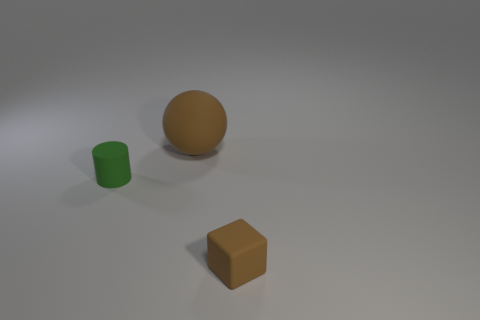What shape is the tiny object that is the same color as the big ball?
Your answer should be very brief. Cube. Is the color of the tiny object in front of the cylinder the same as the thing to the left of the matte ball?
Provide a succinct answer. No. What number of brown matte things are in front of the tiny cylinder?
Offer a very short reply. 1. There is a matte cube that is the same color as the big matte sphere; what is its size?
Keep it short and to the point. Small. Is there a small matte object that has the same shape as the large brown object?
Keep it short and to the point. No. What color is the matte cylinder that is the same size as the brown cube?
Offer a terse response. Green. Is the number of brown balls in front of the sphere less than the number of large matte balls behind the tiny rubber block?
Your response must be concise. Yes. There is a rubber thing in front of the green matte thing; is its size the same as the green matte object?
Your answer should be compact. Yes. There is a brown matte object that is in front of the rubber cylinder; what is its shape?
Give a very brief answer. Cube. Is the number of green rubber cylinders greater than the number of large purple metal things?
Offer a terse response. Yes. 